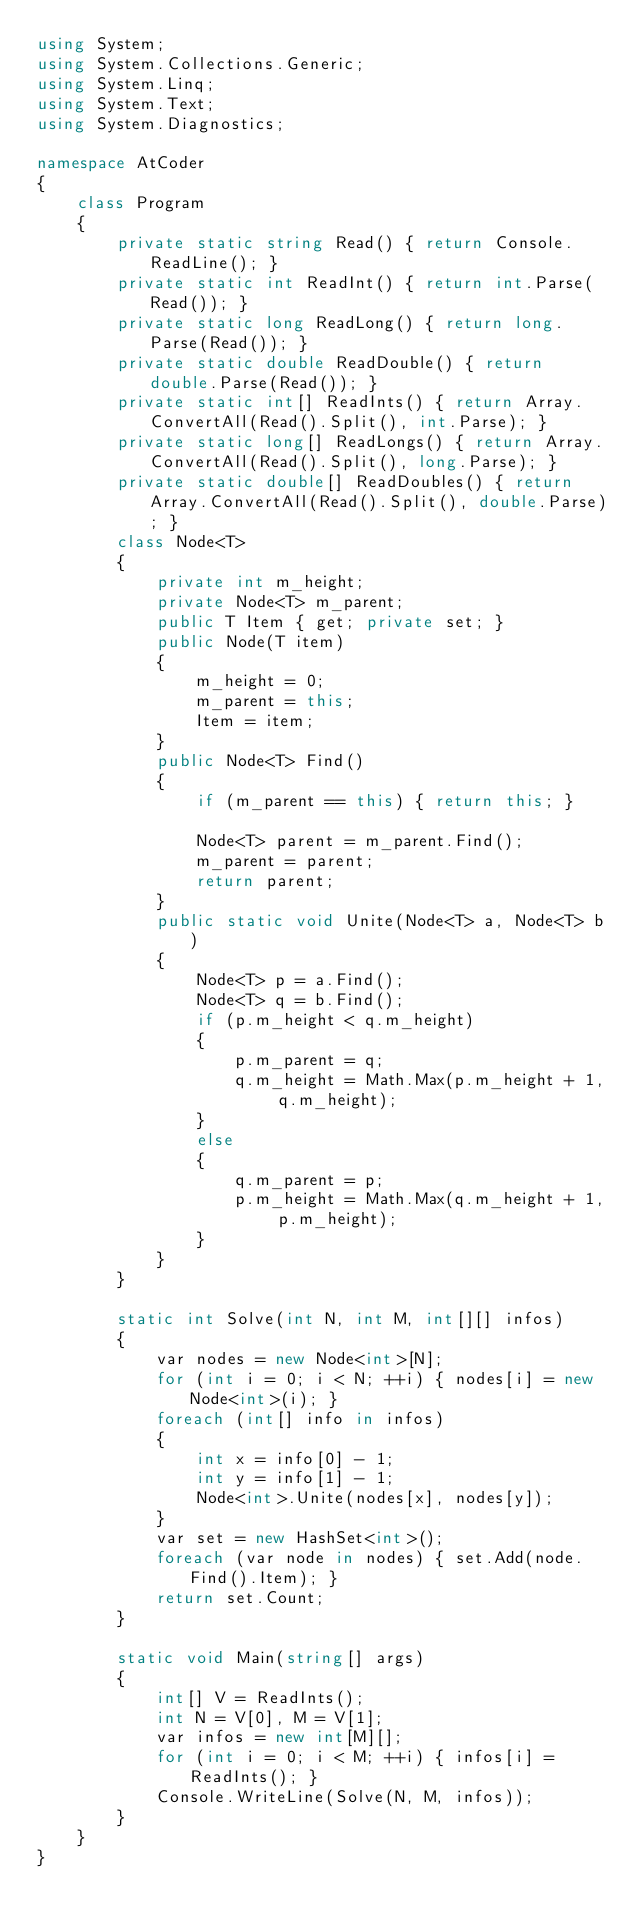<code> <loc_0><loc_0><loc_500><loc_500><_C#_>using System;
using System.Collections.Generic;
using System.Linq;
using System.Text;
using System.Diagnostics;

namespace AtCoder
{
    class Program
    {
        private static string Read() { return Console.ReadLine(); }
        private static int ReadInt() { return int.Parse(Read()); }
        private static long ReadLong() { return long.Parse(Read()); }
        private static double ReadDouble() { return double.Parse(Read()); }
        private static int[] ReadInts() { return Array.ConvertAll(Read().Split(), int.Parse); }
        private static long[] ReadLongs() { return Array.ConvertAll(Read().Split(), long.Parse); }
        private static double[] ReadDoubles() { return Array.ConvertAll(Read().Split(), double.Parse); }
        class Node<T>
        {
            private int m_height;
            private Node<T> m_parent;
            public T Item { get; private set; }
            public Node(T item)
            {
                m_height = 0;
                m_parent = this;
                Item = item;
            }
            public Node<T> Find()
            {
                if (m_parent == this) { return this; }

                Node<T> parent = m_parent.Find();
                m_parent = parent;
                return parent;
            }
            public static void Unite(Node<T> a, Node<T> b)
            {
                Node<T> p = a.Find();
                Node<T> q = b.Find();
                if (p.m_height < q.m_height)
                {
                    p.m_parent = q;
                    q.m_height = Math.Max(p.m_height + 1, q.m_height);
                }
                else
                {
                    q.m_parent = p;
                    p.m_height = Math.Max(q.m_height + 1, p.m_height);
                }
            }
        }

        static int Solve(int N, int M, int[][] infos)
        {
            var nodes = new Node<int>[N];
            for (int i = 0; i < N; ++i) { nodes[i] = new Node<int>(i); }
            foreach (int[] info in infos)
            {
                int x = info[0] - 1;
                int y = info[1] - 1;
                Node<int>.Unite(nodes[x], nodes[y]);
            }
            var set = new HashSet<int>();
            foreach (var node in nodes) { set.Add(node.Find().Item); }
            return set.Count;
        }

        static void Main(string[] args)
        {
            int[] V = ReadInts();
            int N = V[0], M = V[1];
            var infos = new int[M][];
            for (int i = 0; i < M; ++i) { infos[i] = ReadInts(); }
            Console.WriteLine(Solve(N, M, infos));
        }
    }
}
</code> 